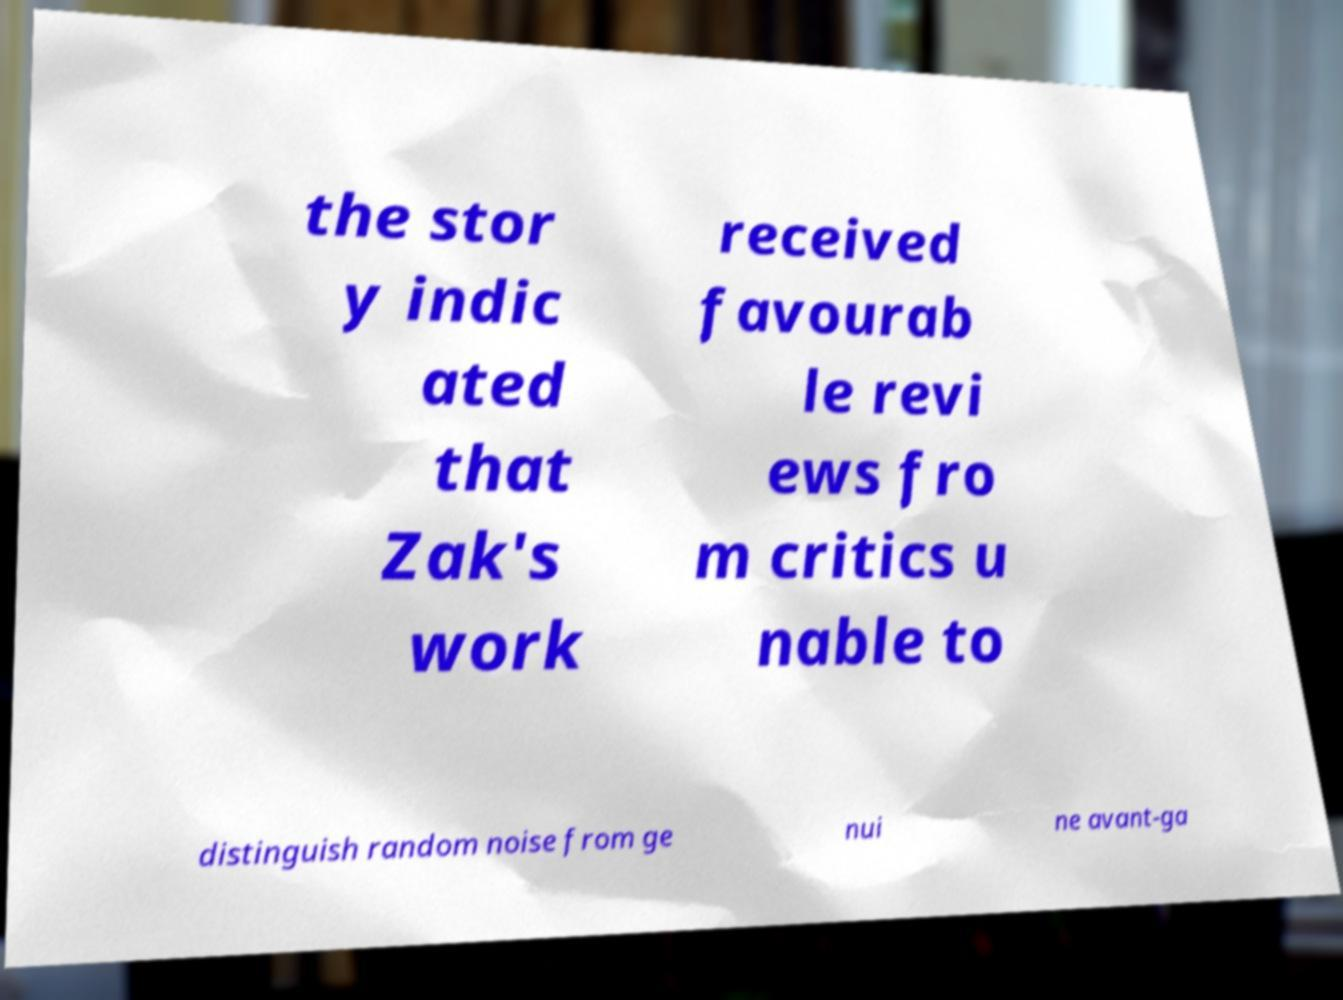There's text embedded in this image that I need extracted. Can you transcribe it verbatim? the stor y indic ated that Zak's work received favourab le revi ews fro m critics u nable to distinguish random noise from ge nui ne avant-ga 